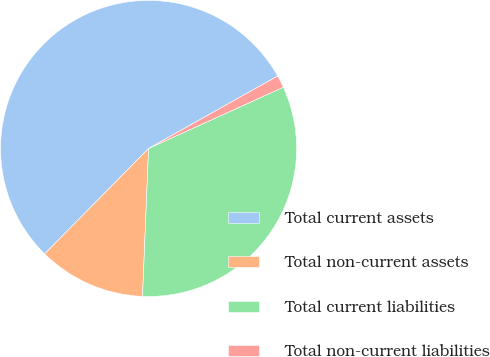Convert chart. <chart><loc_0><loc_0><loc_500><loc_500><pie_chart><fcel>Total current assets<fcel>Total non-current assets<fcel>Total current liabilities<fcel>Total non-current liabilities<nl><fcel>54.48%<fcel>11.74%<fcel>32.44%<fcel>1.35%<nl></chart> 